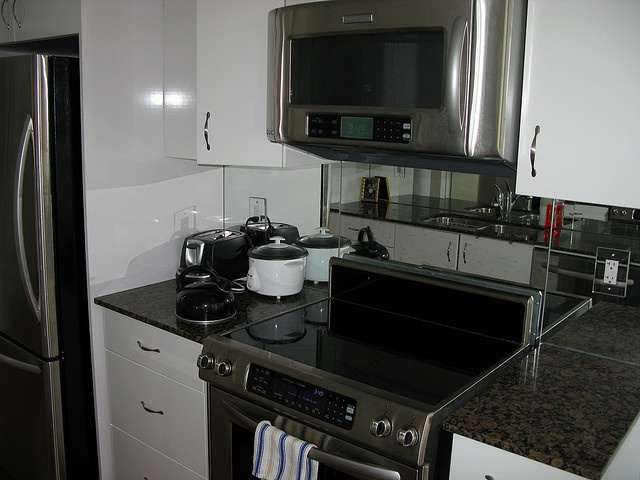Describe the objects in this image and their specific colors. I can see oven in gray, black, and darkgray tones, microwave in gray, black, and darkgray tones, refrigerator in gray, black, darkgreen, and darkgray tones, clock in gray, black, purple, and darkblue tones, and sink in gray and black tones in this image. 